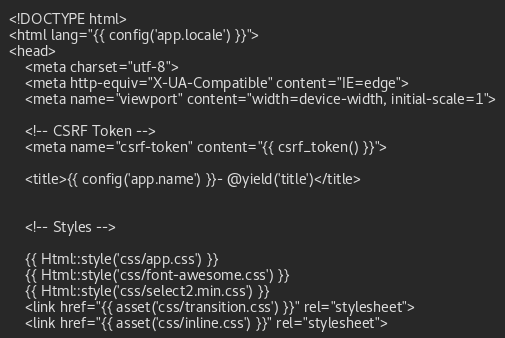<code> <loc_0><loc_0><loc_500><loc_500><_PHP_><!DOCTYPE html>
<html lang="{{ config('app.locale') }}">
<head>
    <meta charset="utf-8">
    <meta http-equiv="X-UA-Compatible" content="IE=edge">
    <meta name="viewport" content="width=device-width, initial-scale=1">

    <!-- CSRF Token -->
    <meta name="csrf-token" content="{{ csrf_token() }}">

    <title>{{ config('app.name') }}- @yield('title')</title>


    <!-- Styles -->

    {{ Html::style('css/app.css') }}
    {{ Html::style('css/font-awesome.css') }}
    {{ Html::style('css/select2.min.css') }}
    <link href="{{ asset('css/transition.css') }}" rel="stylesheet">
    <link href="{{ asset('css/inline.css') }}" rel="stylesheet"></code> 